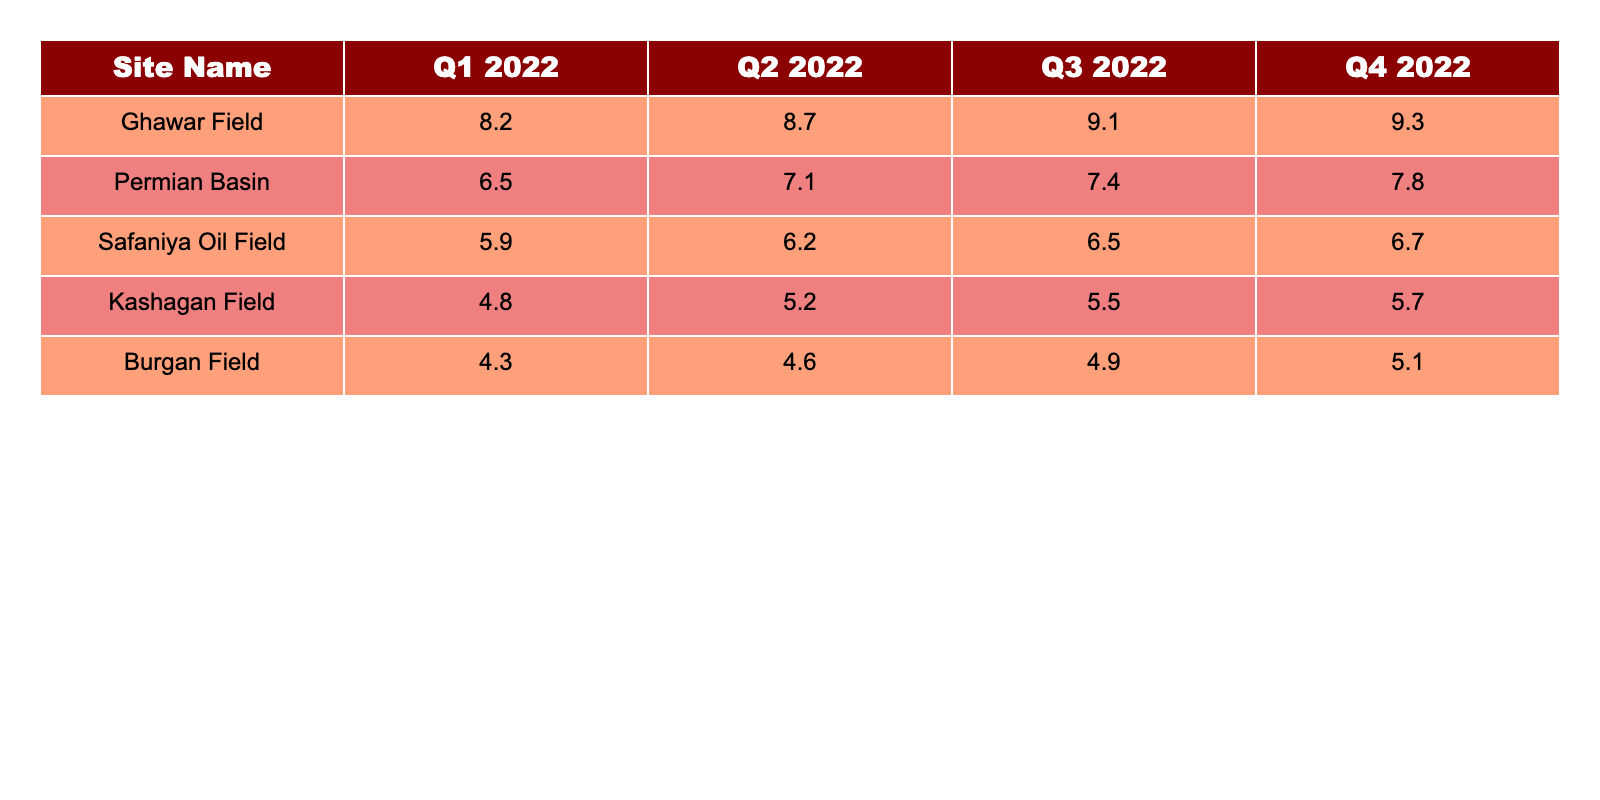What was the total revenue generated by the Ghawar Field in 2022? To find the total revenue generated by the Ghawar Field, we sum the quarterly revenues: 8.2 + 8.7 + 9.1 + 9.3 = 34.3.
Answer: 34.3 Which oil field had the highest revenue in Q3 2022? In Q3 2022, the Ghawar Field generated 9.1, which is higher than any other field.
Answer: Ghawar Field What was the average revenue of the Permian Basin across the four quarters? The average revenue is calculated by summing the quarters' revenues (6.5 + 7.1 + 7.4 + 7.8 = 28.8) and dividing by 4, giving us 28.8 / 4 = 7.2.
Answer: 7.2 Did the Burgan Field generate more revenue in Q4 2022 than in Q1 2022? Q4 2022 revenue was 5.1, while Q1 2022 revenue was 4.3. Since 5.1 > 4.3, this statement is true.
Answer: Yes What is the difference in total revenue between the Safaniya Oil Field and the Kashagan Field for the year 2022? For Safaniya, we have 5.9 + 6.2 + 6.5 + 6.7 = 25.3. For Kashagan, we have 4.8 + 5.2 + 5.5 + 5.7 = 21.2. The difference is 25.3 - 21.2 = 4.1.
Answer: 4.1 Which site experienced the largest increase in revenue from Q1 to Q4 2022? For Ghawar Field, the increase is 9.3 - 8.2 = 1.1; for Permian Basin, it is 7.8 - 6.5 = 1.3; for Safaniya, it is 6.7 - 5.9 = 0.8; for Kashagan, it is 5.7 - 4.8 = 0.9; for Burgan, it is 5.1 - 4.3 = 0.8. The largest increase is 1.3 from the Permian Basin.
Answer: Permian Basin What is the total revenue for all five oil fields combined in Q2 2022? Summing up the revenues for Q2 gives: 8.7 + 7.1 + 6.2 + 5.2 + 4.6 = 31.8.
Answer: 31.8 Is the total revenue for the top 5 oil fields greater than 150 for the year 2022? The total revenue amounts are: Ghawar 34.3, Permian 28.8, Safaniya 25.3, Kashagan 21.2, and Burgan 20.9. Summing them gives 34.3 + 28.8 + 25.3 + 21.2 + 20.9 = 130.5, which is not greater than 150.
Answer: No What is the trend of the total revenue across the quarters for the Ghawar Field? The revenues for Ghawar Field are consistently increasing each quarter: Q1 = 8.2, Q2 = 8.7, Q3 = 9.1, Q4 = 9.3, which indicates a positive trend.
Answer: Increasing Which oil drilling site had the lowest revenue in total for 2022? Adding the totals for each site shows that Burgan Field has the lowest total: 4.3 + 4.6 + 4.9 + 5.1 = 20.9.
Answer: Burgan Field 